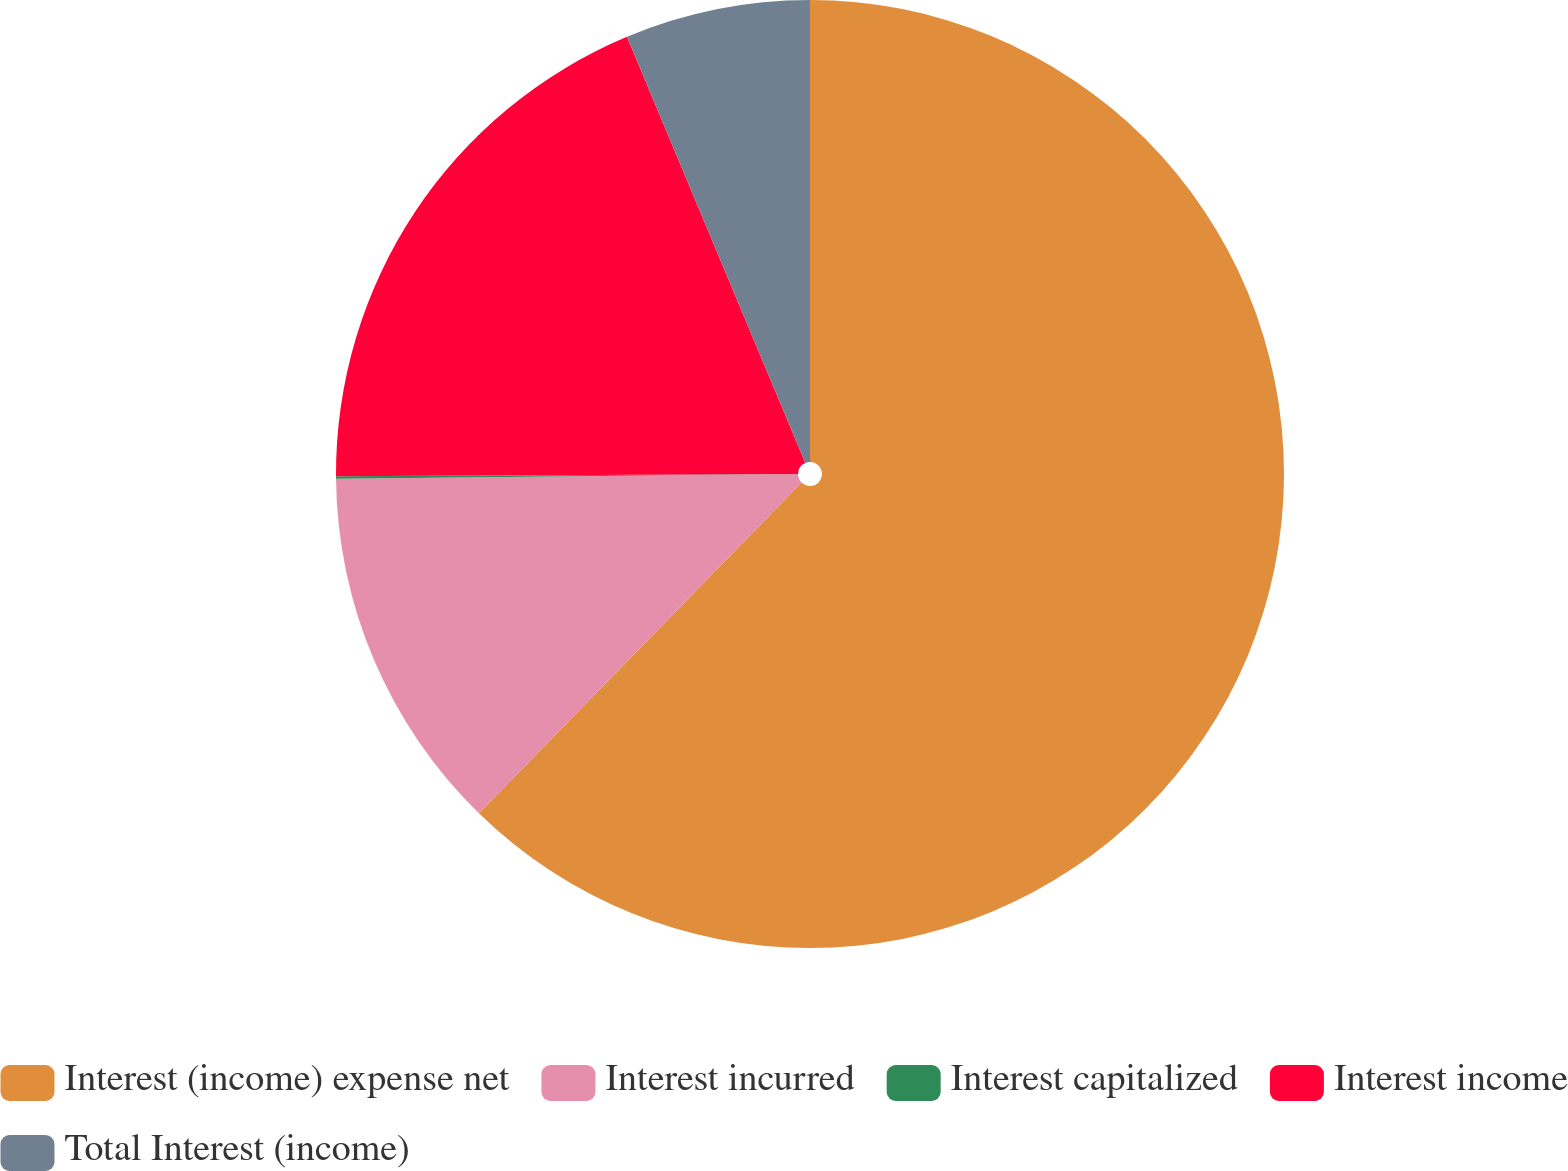Convert chart to OTSL. <chart><loc_0><loc_0><loc_500><loc_500><pie_chart><fcel>Interest (income) expense net<fcel>Interest incurred<fcel>Interest capitalized<fcel>Interest income<fcel>Total Interest (income)<nl><fcel>62.3%<fcel>12.53%<fcel>0.09%<fcel>18.76%<fcel>6.31%<nl></chart> 